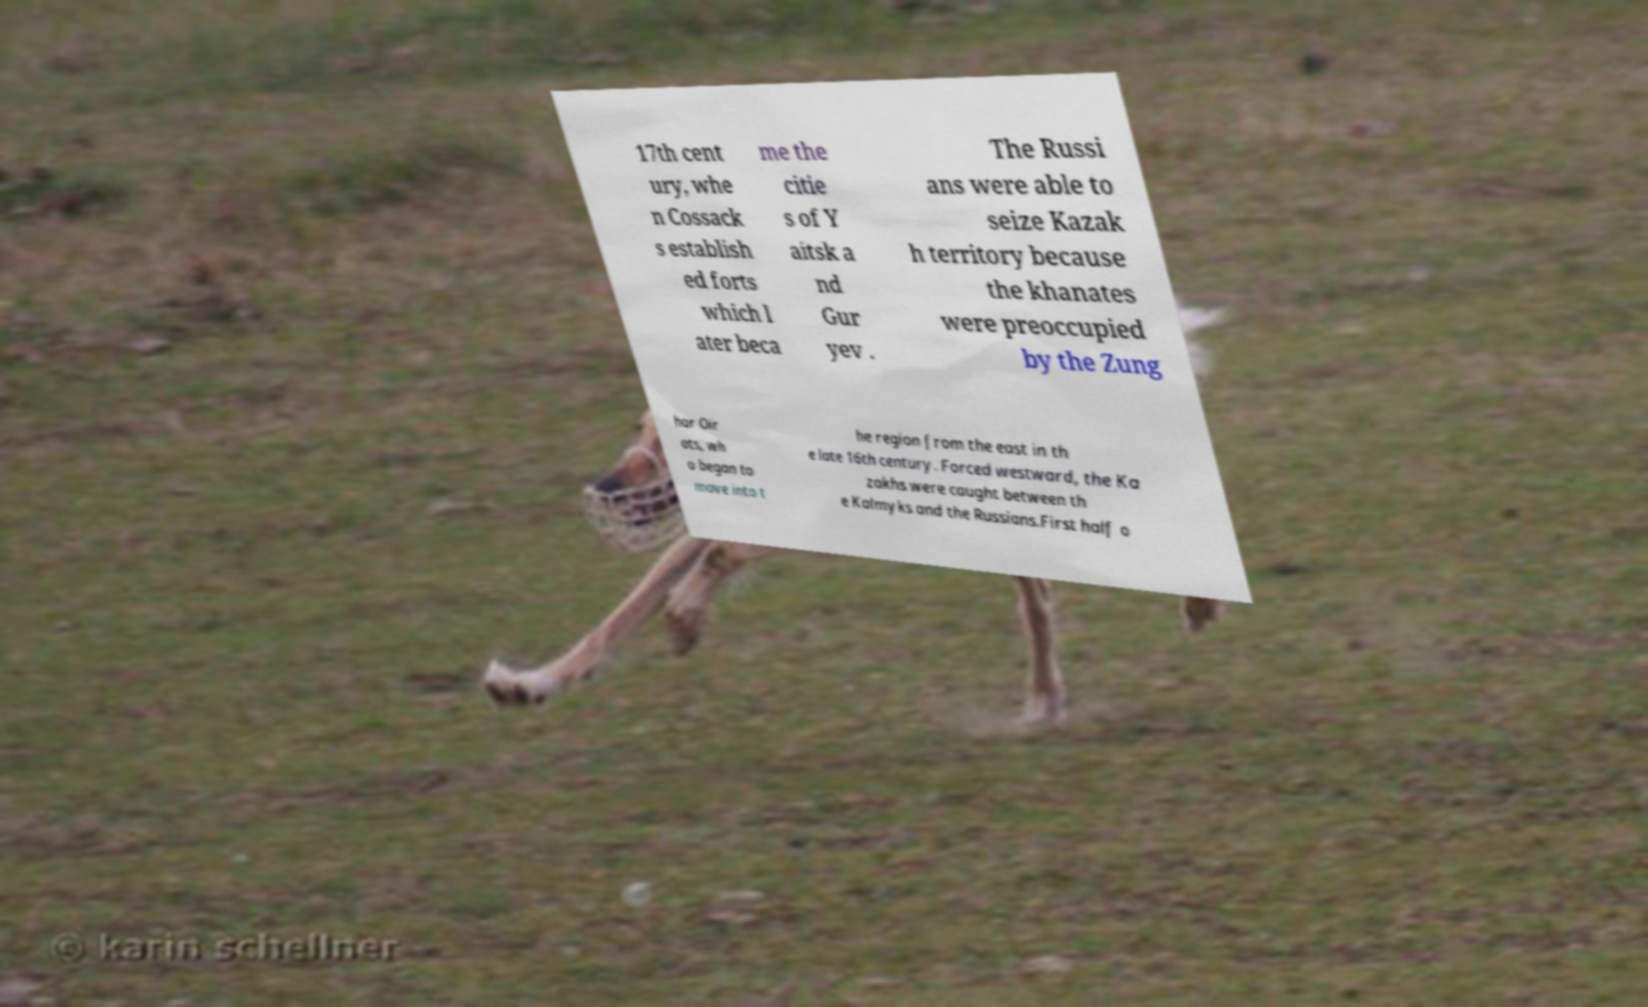Can you accurately transcribe the text from the provided image for me? 17th cent ury, whe n Cossack s establish ed forts which l ater beca me the citie s of Y aitsk a nd Gur yev . The Russi ans were able to seize Kazak h territory because the khanates were preoccupied by the Zung har Oir ats, wh o began to move into t he region from the east in th e late 16th century. Forced westward, the Ka zakhs were caught between th e Kalmyks and the Russians.First half o 